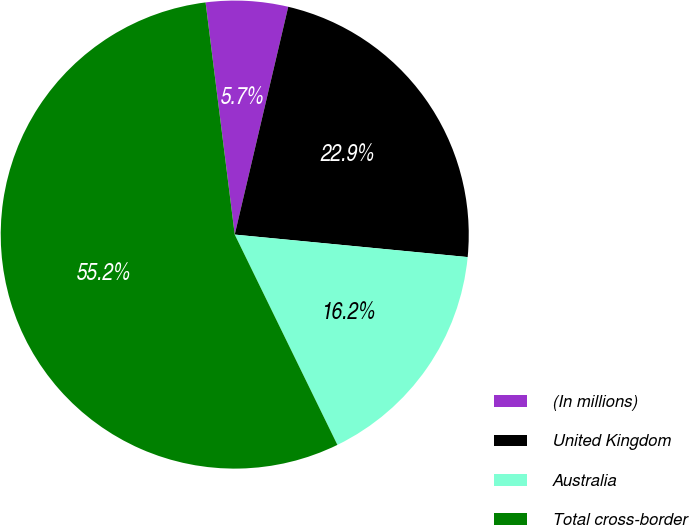<chart> <loc_0><loc_0><loc_500><loc_500><pie_chart><fcel>(In millions)<fcel>United Kingdom<fcel>Australia<fcel>Total cross-border<nl><fcel>5.66%<fcel>22.86%<fcel>16.24%<fcel>55.24%<nl></chart> 